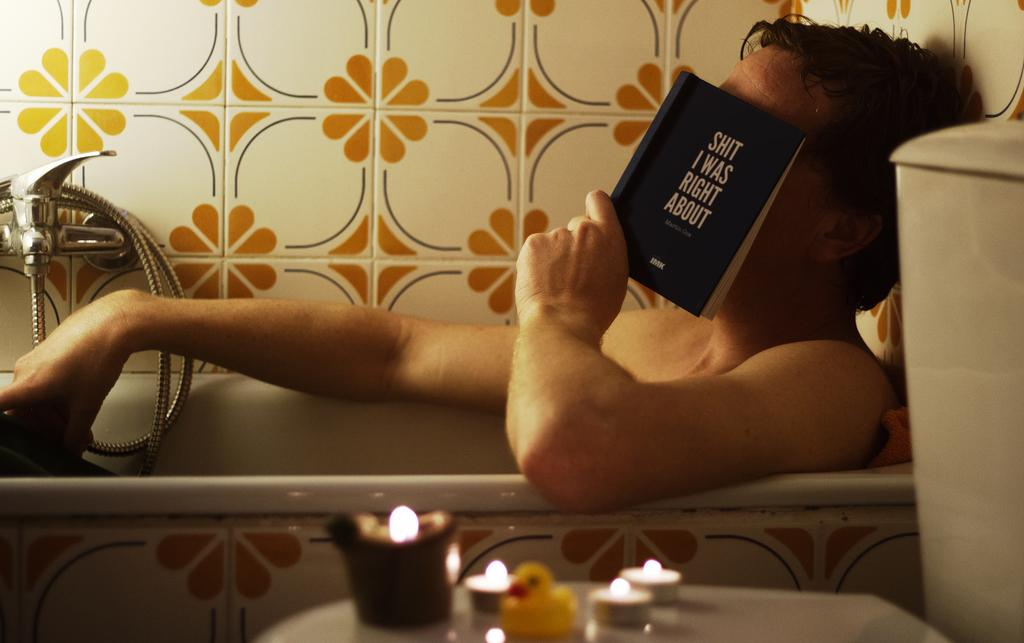<image>
Provide a brief description of the given image. A man in the tub, covering his face with a book called Shit I was Right About. 